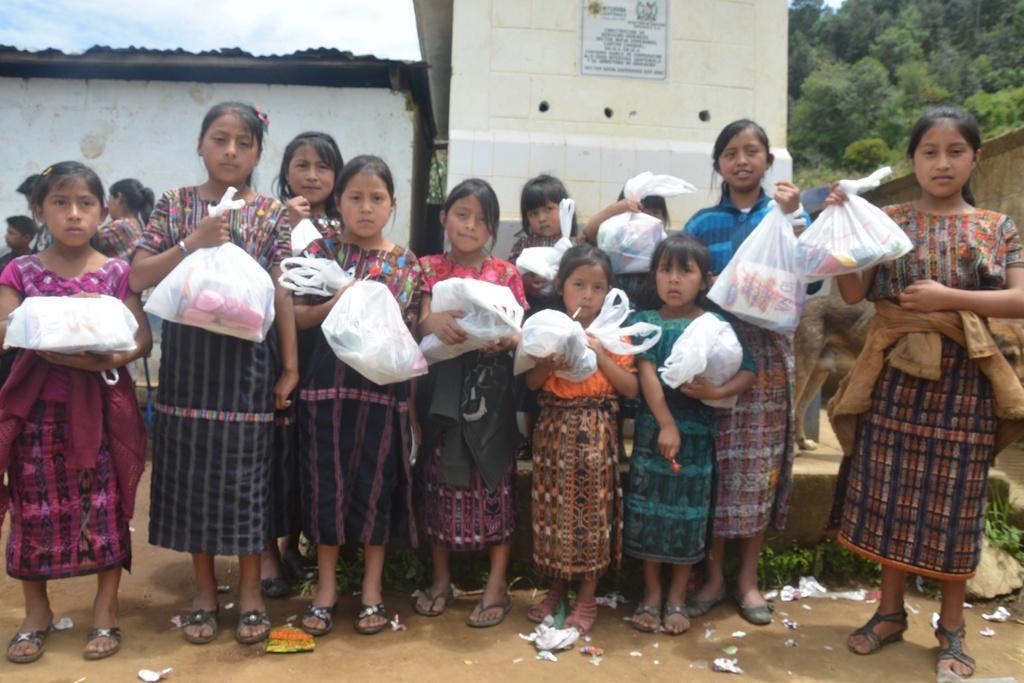How would you summarize this image in a sentence or two? In this picture I can see couple of houses in the back and few girls standing holding carry bags in their hands and I can see trees on the top right corner and I can see blue cloudy sky on the top left and I can see a poster on the wall with some text and I can see few people standing at the back. 